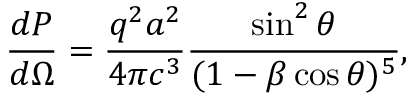Convert formula to latex. <formula><loc_0><loc_0><loc_500><loc_500>{ \frac { d P } { d \Omega } } = { \frac { q ^ { 2 } a ^ { 2 } } { 4 \pi c ^ { 3 } } } { \frac { \sin ^ { 2 } \theta } { ( 1 - \beta \cos \theta ) ^ { 5 } } } ,</formula> 